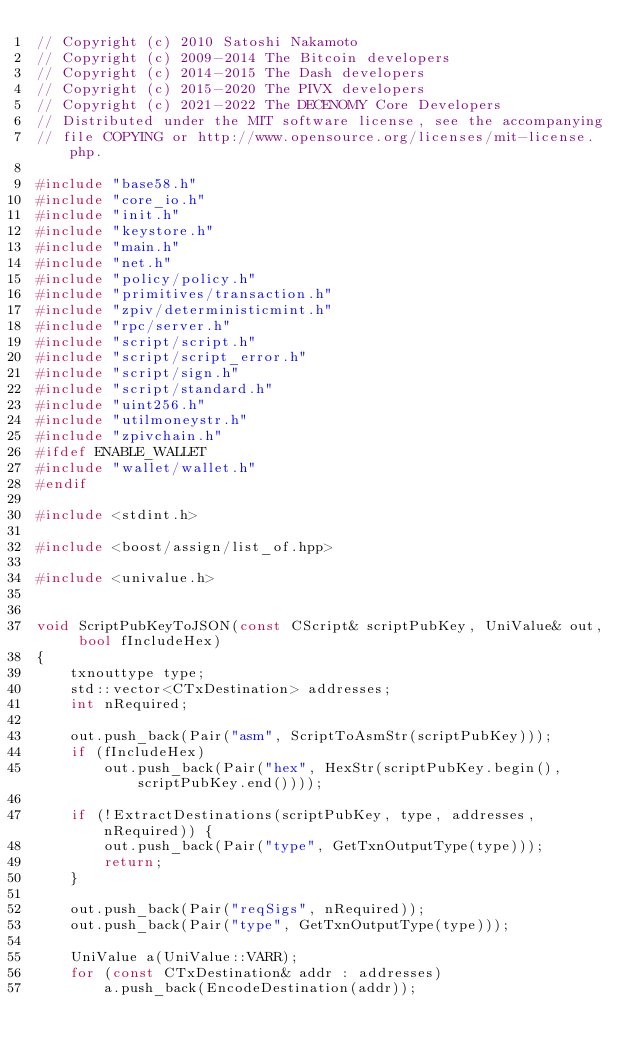<code> <loc_0><loc_0><loc_500><loc_500><_C++_>// Copyright (c) 2010 Satoshi Nakamoto
// Copyright (c) 2009-2014 The Bitcoin developers
// Copyright (c) 2014-2015 The Dash developers
// Copyright (c) 2015-2020 The PIVX developers
// Copyright (c) 2021-2022 The DECENOMY Core Developers
// Distributed under the MIT software license, see the accompanying
// file COPYING or http://www.opensource.org/licenses/mit-license.php.

#include "base58.h"
#include "core_io.h"
#include "init.h"
#include "keystore.h"
#include "main.h"
#include "net.h"
#include "policy/policy.h"
#include "primitives/transaction.h"
#include "zpiv/deterministicmint.h"
#include "rpc/server.h"
#include "script/script.h"
#include "script/script_error.h"
#include "script/sign.h"
#include "script/standard.h"
#include "uint256.h"
#include "utilmoneystr.h"
#include "zpivchain.h"
#ifdef ENABLE_WALLET
#include "wallet/wallet.h"
#endif

#include <stdint.h>

#include <boost/assign/list_of.hpp>

#include <univalue.h>


void ScriptPubKeyToJSON(const CScript& scriptPubKey, UniValue& out, bool fIncludeHex)
{
    txnouttype type;
    std::vector<CTxDestination> addresses;
    int nRequired;

    out.push_back(Pair("asm", ScriptToAsmStr(scriptPubKey)));
    if (fIncludeHex)
        out.push_back(Pair("hex", HexStr(scriptPubKey.begin(), scriptPubKey.end())));

    if (!ExtractDestinations(scriptPubKey, type, addresses, nRequired)) {
        out.push_back(Pair("type", GetTxnOutputType(type)));
        return;
    }

    out.push_back(Pair("reqSigs", nRequired));
    out.push_back(Pair("type", GetTxnOutputType(type)));

    UniValue a(UniValue::VARR);
    for (const CTxDestination& addr : addresses)
        a.push_back(EncodeDestination(addr));</code> 